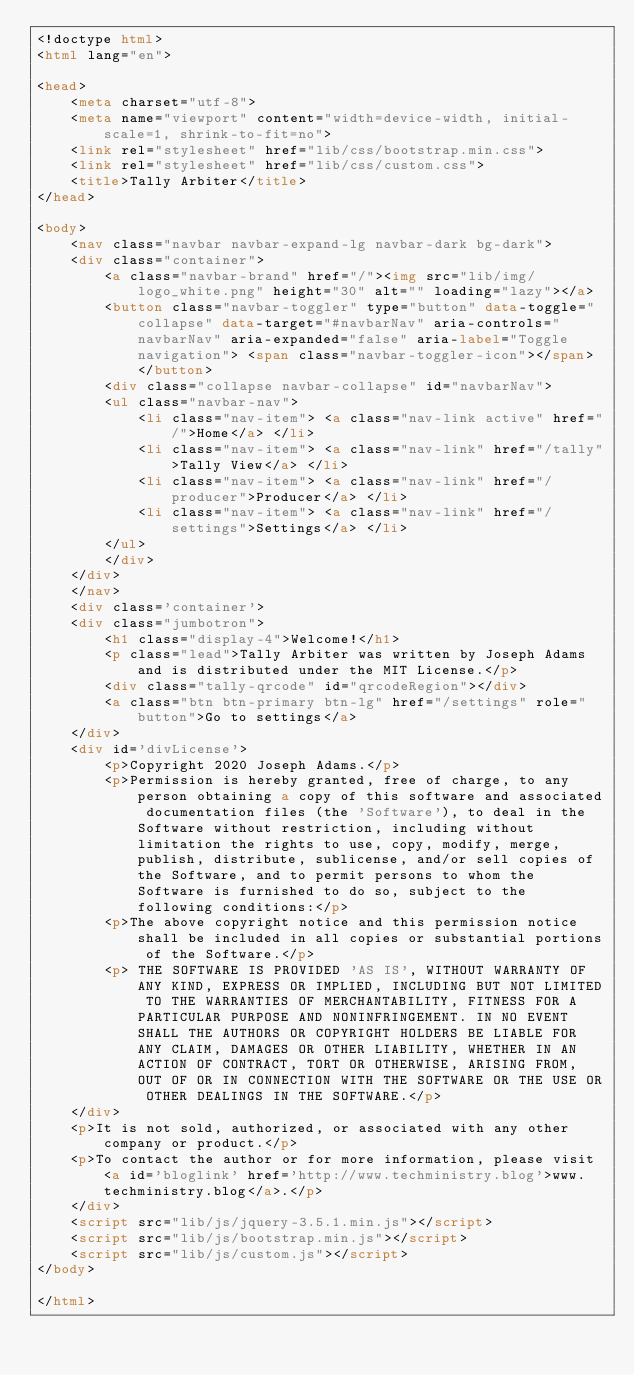Convert code to text. <code><loc_0><loc_0><loc_500><loc_500><_HTML_><!doctype html>
<html lang="en">

<head>
	<meta charset="utf-8">
	<meta name="viewport" content="width=device-width, initial-scale=1, shrink-to-fit=no">
	<link rel="stylesheet" href="lib/css/bootstrap.min.css">
	<link rel="stylesheet" href="lib/css/custom.css">
	<title>Tally Arbiter</title>
</head>

<body>
	<nav class="navbar navbar-expand-lg navbar-dark bg-dark">
	<div class="container">
		<a class="navbar-brand" href="/"><img src="lib/img/logo_white.png" height="30" alt="" loading="lazy"></a>
		<button class="navbar-toggler" type="button" data-toggle="collapse" data-target="#navbarNav" aria-controls="navbarNav" aria-expanded="false" aria-label="Toggle navigation"> <span class="navbar-toggler-icon"></span> </button>
		<div class="collapse navbar-collapse" id="navbarNav">
		<ul class="navbar-nav">
			<li class="nav-item"> <a class="nav-link active" href="/">Home</a> </li>
			<li class="nav-item"> <a class="nav-link" href="/tally">Tally View</a> </li>
			<li class="nav-item"> <a class="nav-link" href="/producer">Producer</a> </li>
			<li class="nav-item"> <a class="nav-link" href="/settings">Settings</a> </li>
		</ul>
		</div>
	</div>
	</nav>
	<div class='container'>
	<div class="jumbotron">
		<h1 class="display-4">Welcome!</h1>
		<p class="lead">Tally Arbiter was written by Joseph Adams and is distributed under the MIT License.</p>
		<div class="tally-qrcode" id="qrcodeRegion"></div>
		<a class="btn btn-primary btn-lg" href="/settings" role="button">Go to settings</a>
	</div>
	<div id='divLicense'>
		<p>Copyright 2020 Joseph Adams.</p>
		<p>Permission is hereby granted, free of charge, to any person obtaining a copy of this software and associated documentation files (the 'Software'), to deal in the Software without restriction, including without limitation the rights to use, copy, modify, merge, publish, distribute, sublicense, and/or sell copies of the Software, and to permit persons to whom the Software is furnished to do so, subject to the following conditions:</p>
		<p>The above copyright notice and this permission notice shall be included in all copies or substantial portions of the Software.</p>
		<p> THE SOFTWARE IS PROVIDED 'AS IS', WITHOUT WARRANTY OF ANY KIND, EXPRESS OR IMPLIED, INCLUDING BUT NOT LIMITED TO THE WARRANTIES OF MERCHANTABILITY, FITNESS FOR A PARTICULAR PURPOSE AND NONINFRINGEMENT. IN NO EVENT SHALL THE AUTHORS OR COPYRIGHT HOLDERS BE LIABLE FOR ANY CLAIM, DAMAGES OR OTHER LIABILITY, WHETHER IN AN ACTION OF CONTRACT, TORT OR OTHERWISE, ARISING FROM, OUT OF OR IN CONNECTION WITH THE SOFTWARE OR THE USE OR OTHER DEALINGS IN THE SOFTWARE.</p>
	</div>
	<p>It is not sold, authorized, or associated with any other company or product.</p>
	<p>To contact the author or for more information, please visit <a id='bloglink' href='http://www.techministry.blog'>www.techministry.blog</a>.</p>
	</div>
	<script src="lib/js/jquery-3.5.1.min.js"></script>
	<script src="lib/js/bootstrap.min.js"></script>
	<script src="lib/js/custom.js"></script>
</body>

</html></code> 